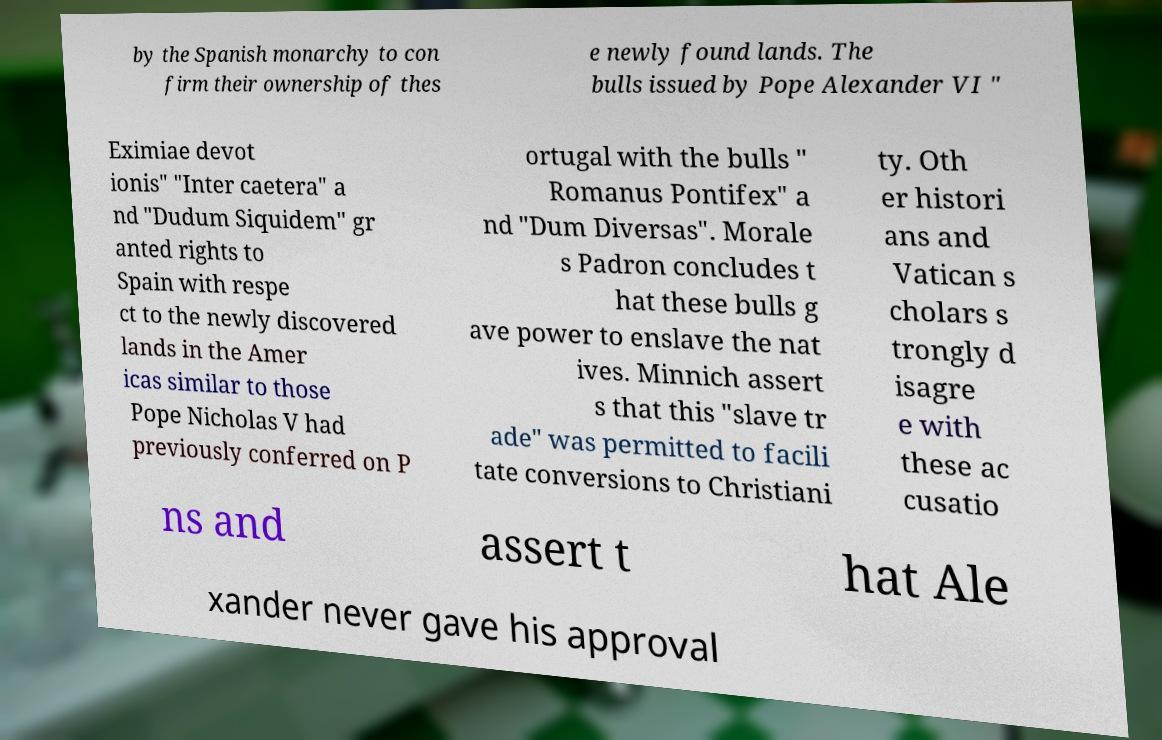There's text embedded in this image that I need extracted. Can you transcribe it verbatim? by the Spanish monarchy to con firm their ownership of thes e newly found lands. The bulls issued by Pope Alexander VI " Eximiae devot ionis" "Inter caetera" a nd "Dudum Siquidem" gr anted rights to Spain with respe ct to the newly discovered lands in the Amer icas similar to those Pope Nicholas V had previously conferred on P ortugal with the bulls " Romanus Pontifex" a nd "Dum Diversas". Morale s Padron concludes t hat these bulls g ave power to enslave the nat ives. Minnich assert s that this "slave tr ade" was permitted to facili tate conversions to Christiani ty. Oth er histori ans and Vatican s cholars s trongly d isagre e with these ac cusatio ns and assert t hat Ale xander never gave his approval 